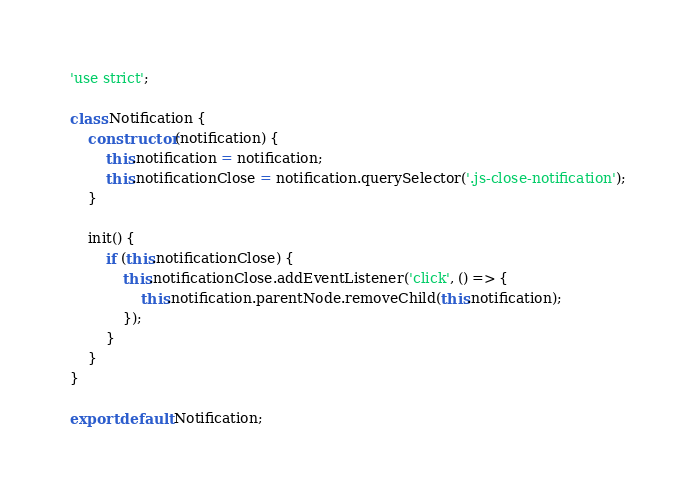Convert code to text. <code><loc_0><loc_0><loc_500><loc_500><_JavaScript_>'use strict';

class Notification {
    constructor (notification) {
        this.notification = notification;
        this.notificationClose = notification.querySelector('.js-close-notification');
    }

    init() {
        if (this.notificationClose) {
            this.notificationClose.addEventListener('click', () => {
                this.notification.parentNode.removeChild(this.notification);
            });
        }
    }
}

export default Notification;
</code> 